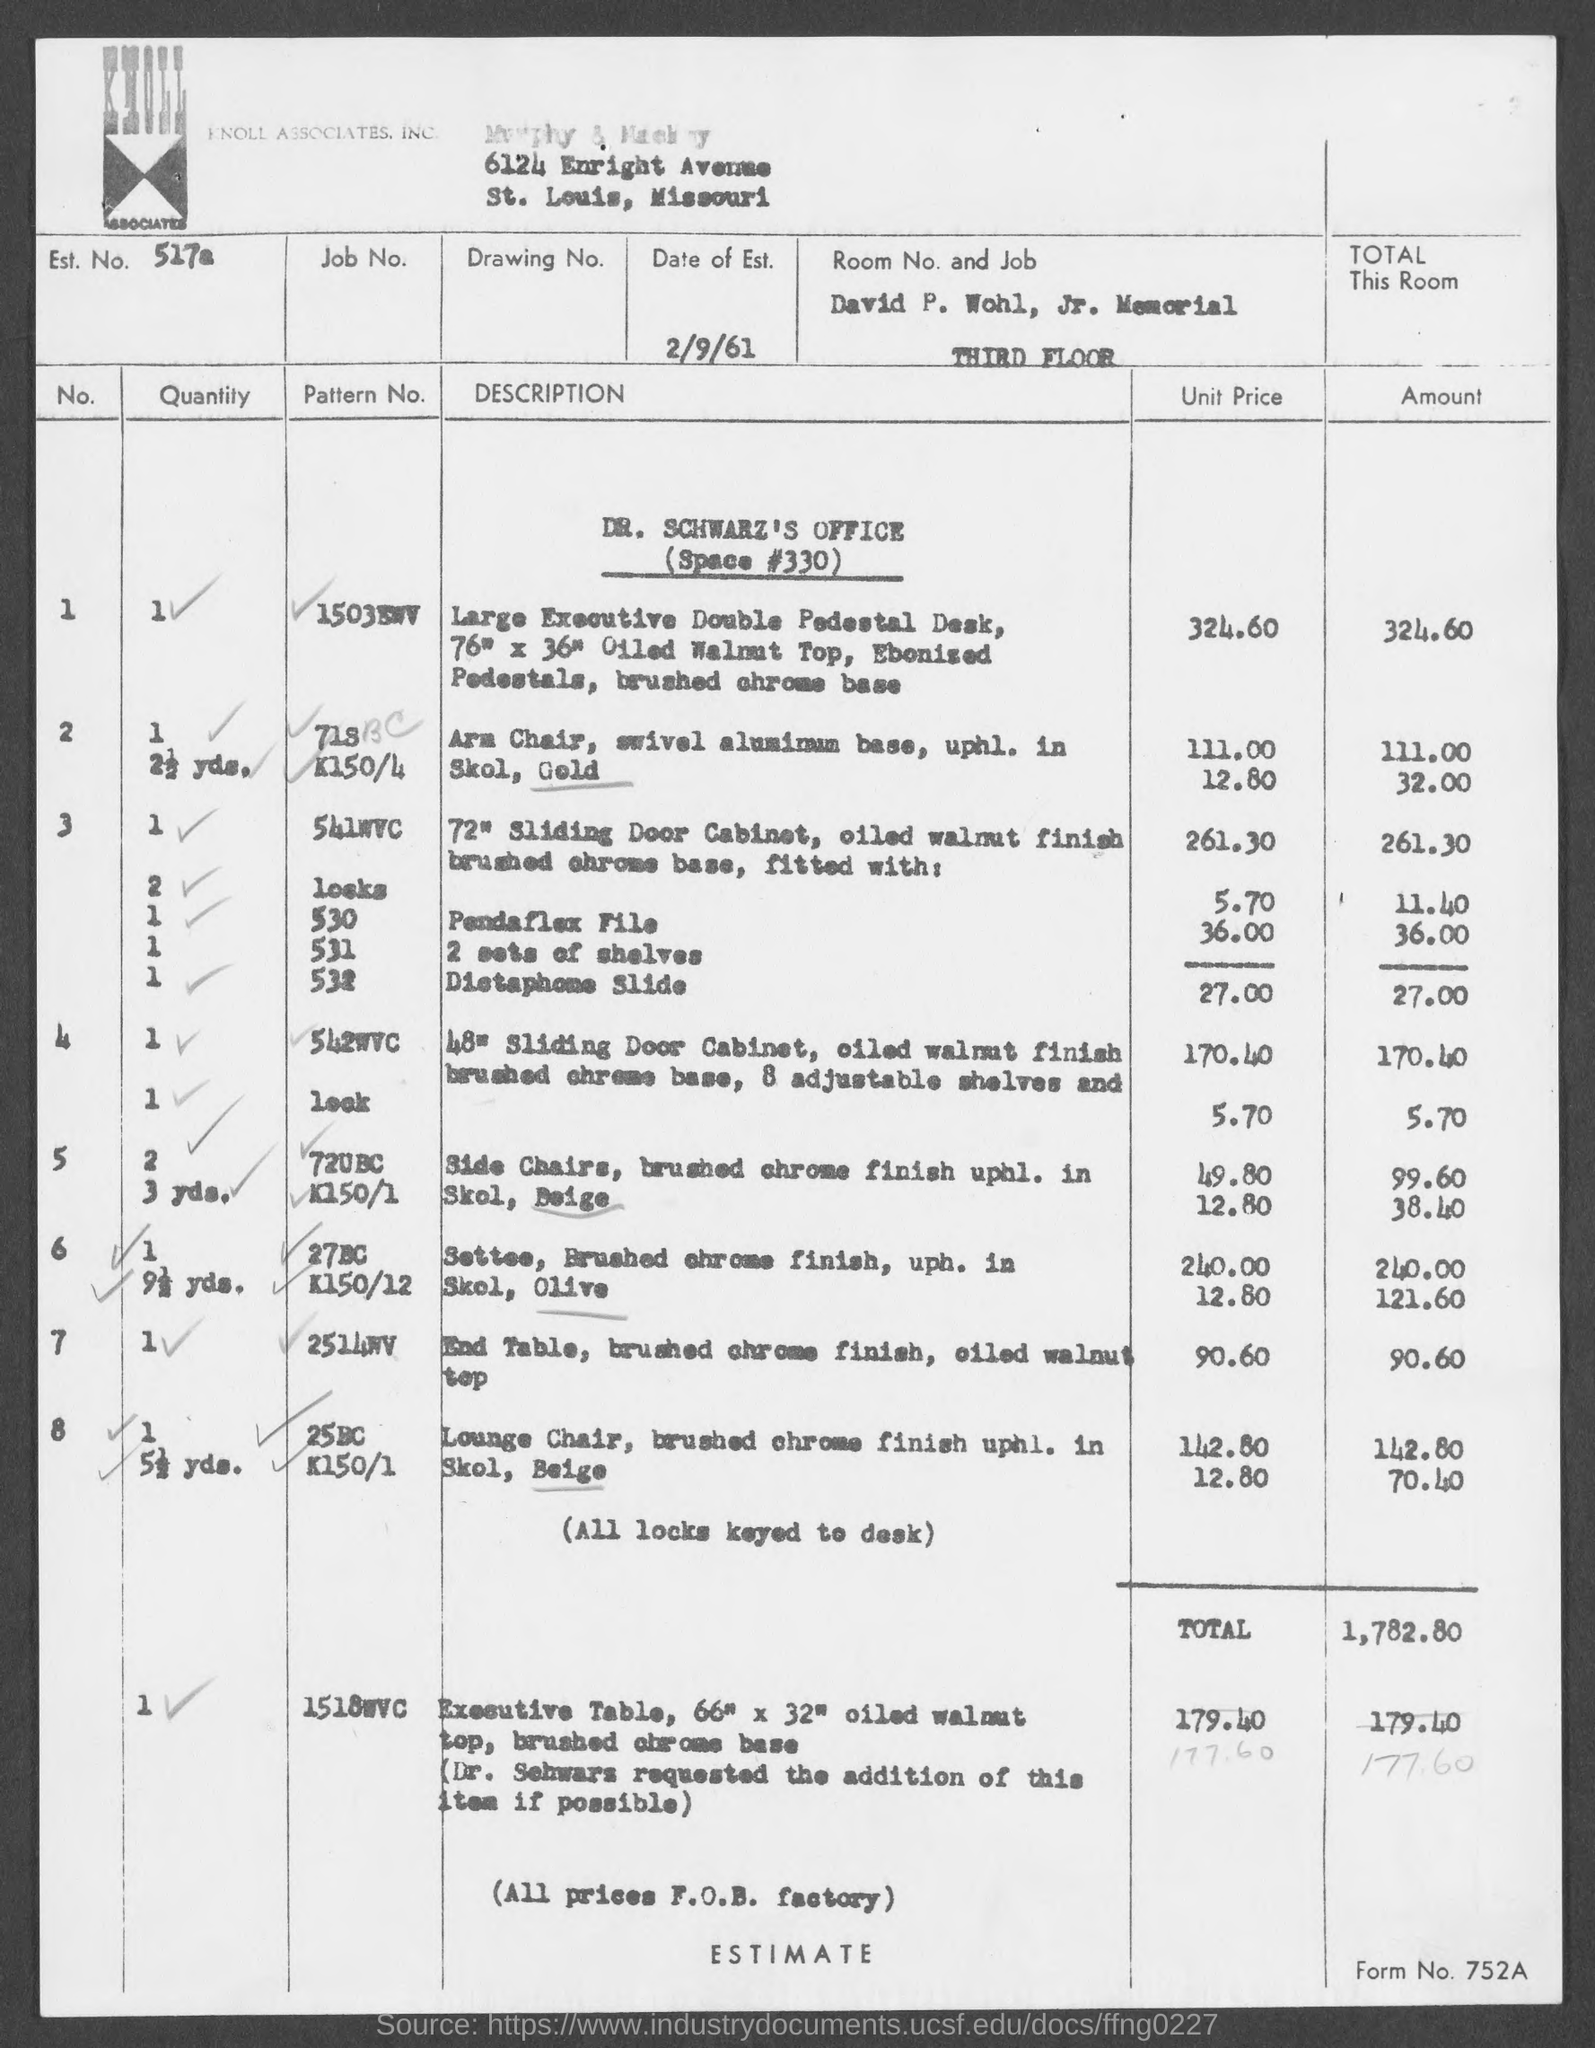What is the Date of Est. given in the document?
Provide a short and direct response. 2/9/61. What is the Est. No. given in the document?
Offer a very short reply. 517a. What is the Form No. given in the document?
Offer a very short reply. 752a. What is the total estimated amount for Dr. Schwarz's Office (Space #330)?
Your answer should be compact. 1,782.80. 